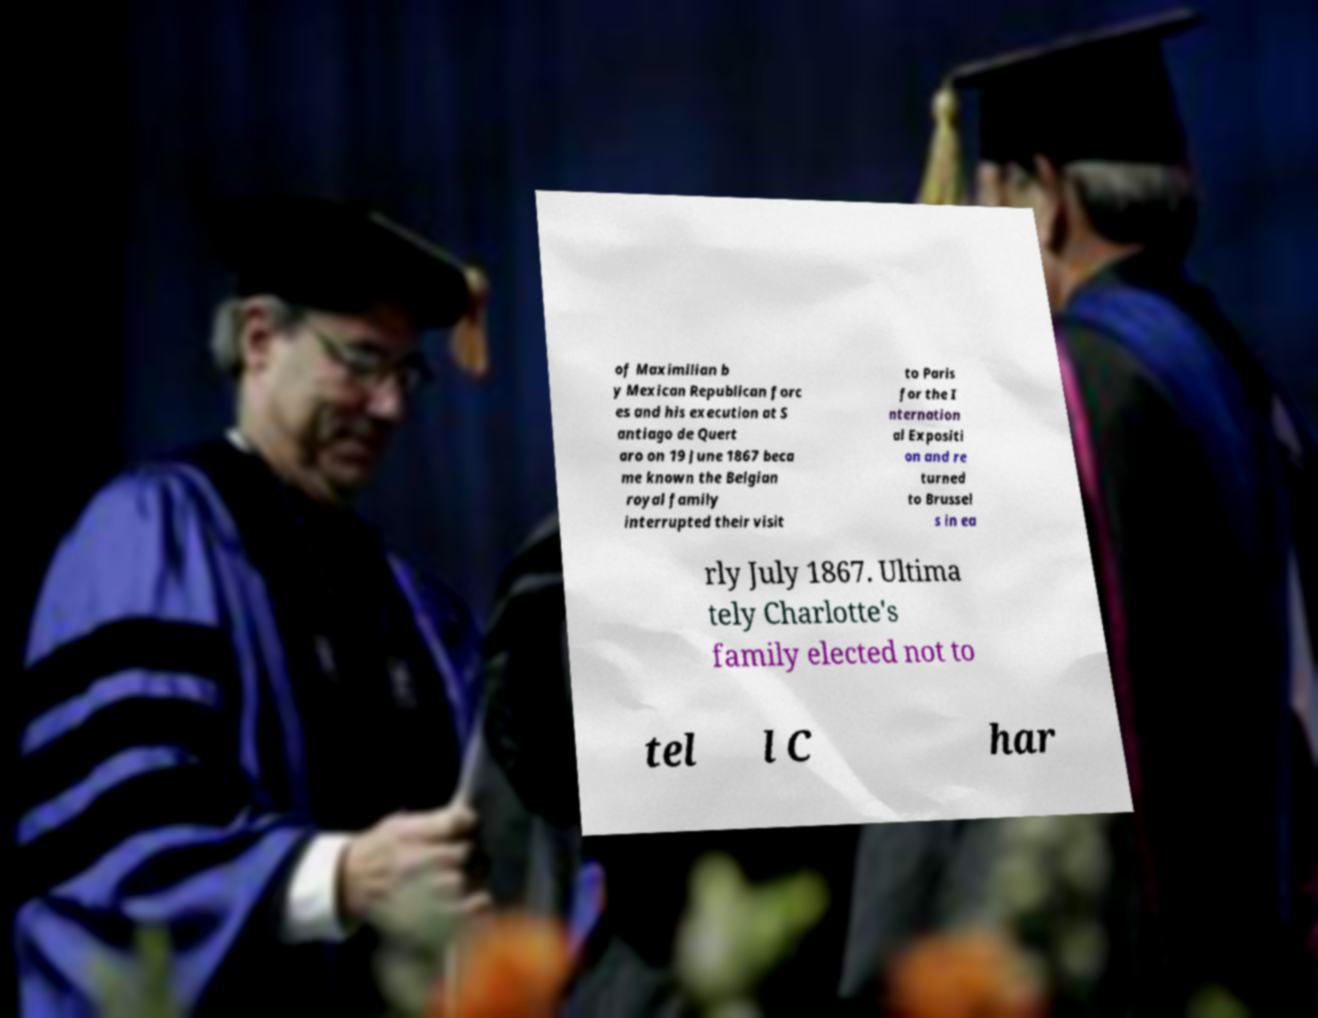Please identify and transcribe the text found in this image. of Maximilian b y Mexican Republican forc es and his execution at S antiago de Quert aro on 19 June 1867 beca me known the Belgian royal family interrupted their visit to Paris for the I nternation al Expositi on and re turned to Brussel s in ea rly July 1867. Ultima tely Charlotte's family elected not to tel l C har 